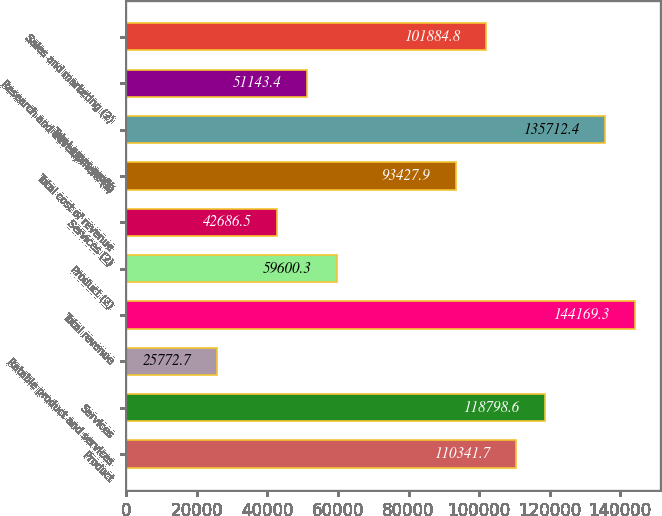Convert chart. <chart><loc_0><loc_0><loc_500><loc_500><bar_chart><fcel>Product<fcel>Services<fcel>Ratable product and services<fcel>Total revenue<fcel>Product (2)<fcel>Services (2)<fcel>Total cost of revenue<fcel>Total gross profit<fcel>Research and development (2)<fcel>Sales and marketing (2)<nl><fcel>110342<fcel>118799<fcel>25772.7<fcel>144169<fcel>59600.3<fcel>42686.5<fcel>93427.9<fcel>135712<fcel>51143.4<fcel>101885<nl></chart> 